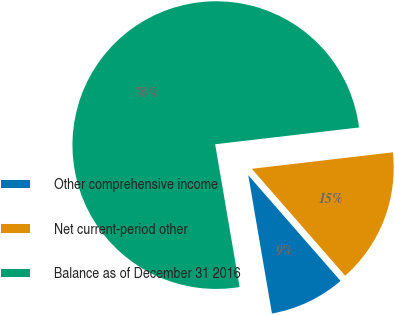Convert chart. <chart><loc_0><loc_0><loc_500><loc_500><pie_chart><fcel>Other comprehensive income<fcel>Net current-period other<fcel>Balance as of December 31 2016<nl><fcel>8.72%<fcel>15.43%<fcel>75.85%<nl></chart> 